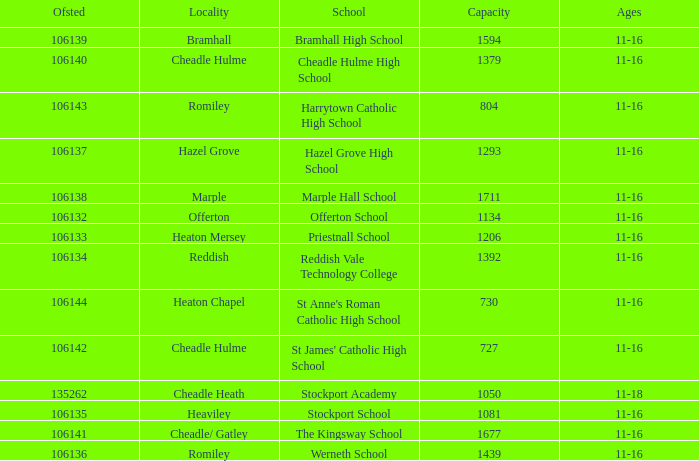Which Ofsted has a Capacity of 1677? 106141.0. 